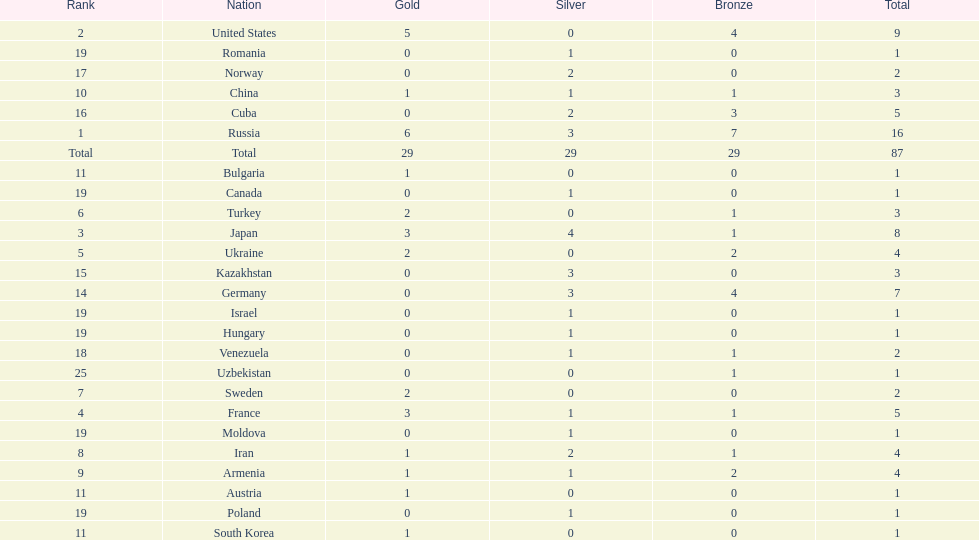Which nation has one gold medal but zero in both silver and bronze? Austria. 